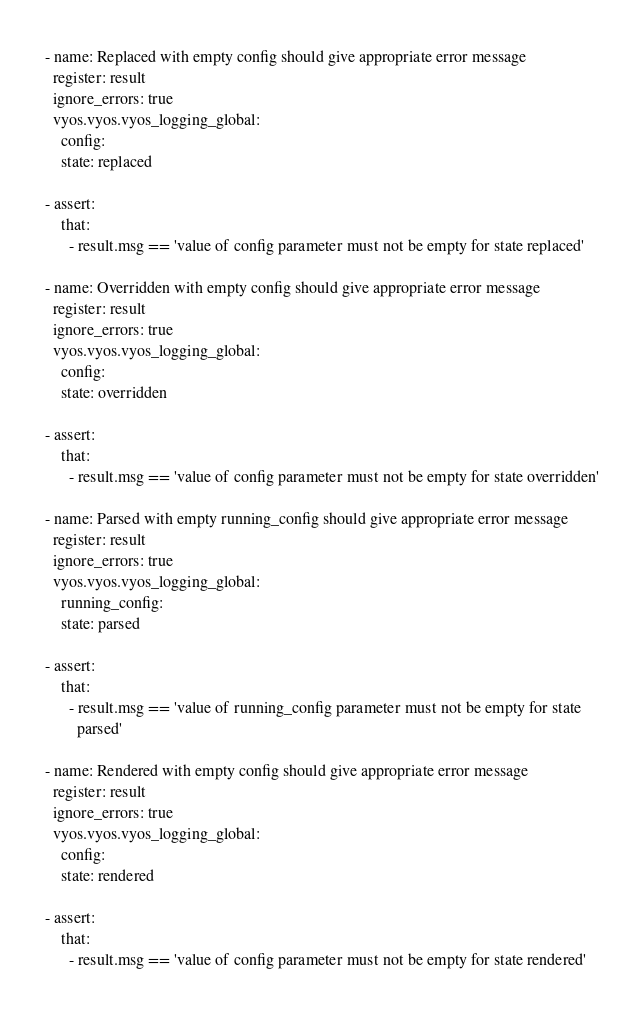<code> <loc_0><loc_0><loc_500><loc_500><_YAML_>- name: Replaced with empty config should give appropriate error message
  register: result
  ignore_errors: true
  vyos.vyos.vyos_logging_global:
    config:
    state: replaced

- assert:
    that:
      - result.msg == 'value of config parameter must not be empty for state replaced'

- name: Overridden with empty config should give appropriate error message
  register: result
  ignore_errors: true
  vyos.vyos.vyos_logging_global:
    config:
    state: overridden

- assert:
    that:
      - result.msg == 'value of config parameter must not be empty for state overridden'

- name: Parsed with empty running_config should give appropriate error message
  register: result
  ignore_errors: true
  vyos.vyos.vyos_logging_global:
    running_config:
    state: parsed

- assert:
    that:
      - result.msg == 'value of running_config parameter must not be empty for state
        parsed'

- name: Rendered with empty config should give appropriate error message
  register: result
  ignore_errors: true
  vyos.vyos.vyos_logging_global:
    config:
    state: rendered

- assert:
    that:
      - result.msg == 'value of config parameter must not be empty for state rendered'
</code> 